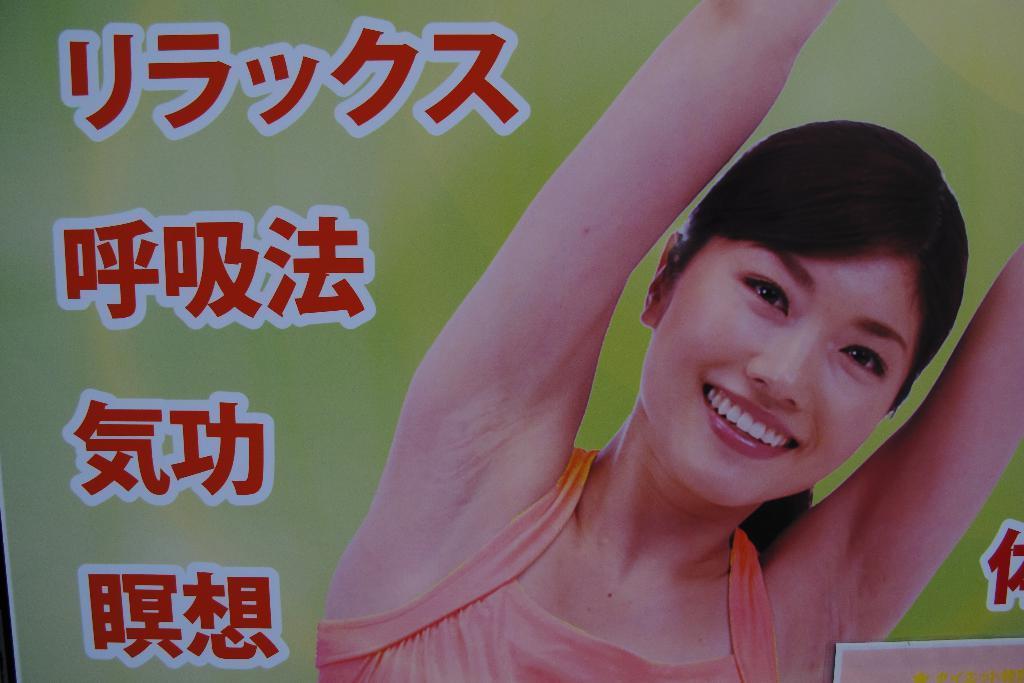Can you describe this image briefly? In this image there is a banner. Something is written on the banner. I can see an image of a woman on the banner. 